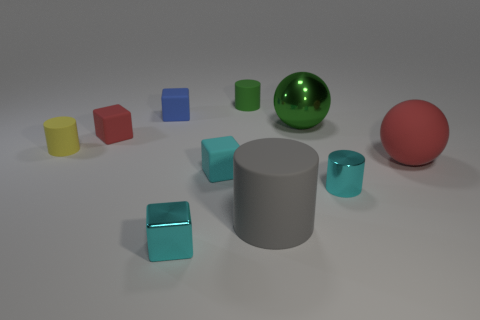What shape is the matte object that is the same color as the large shiny ball?
Ensure brevity in your answer.  Cylinder. What is the color of the large sphere that is on the right side of the cyan shiny cylinder on the right side of the shiny block?
Your response must be concise. Red. What color is the metal cube that is the same size as the green cylinder?
Keep it short and to the point. Cyan. How many small things are green cylinders or green balls?
Give a very brief answer. 1. Is the number of green cylinders left of the small blue matte thing greater than the number of large metallic things that are to the left of the tiny red matte block?
Provide a short and direct response. No. There is a rubber object that is the same color as the small shiny cube; what size is it?
Provide a short and direct response. Small. What number of other things are there of the same size as the red matte cube?
Your response must be concise. 6. Is the material of the small cylinder to the left of the tiny blue thing the same as the blue thing?
Ensure brevity in your answer.  Yes. What number of other things are there of the same color as the shiny ball?
Your answer should be very brief. 1. How many other things are there of the same shape as the yellow rubber object?
Give a very brief answer. 3. 